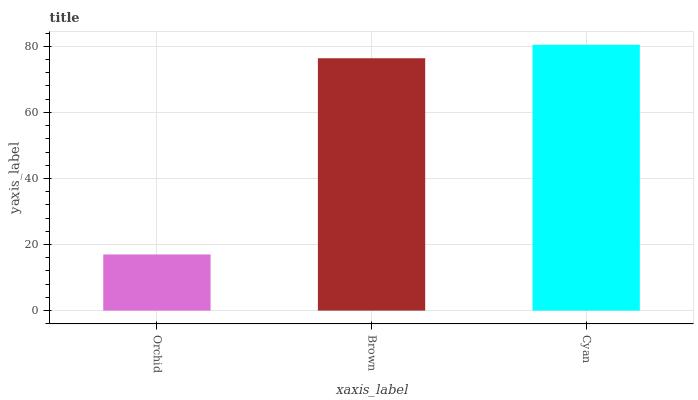Is Brown the minimum?
Answer yes or no. No. Is Brown the maximum?
Answer yes or no. No. Is Brown greater than Orchid?
Answer yes or no. Yes. Is Orchid less than Brown?
Answer yes or no. Yes. Is Orchid greater than Brown?
Answer yes or no. No. Is Brown less than Orchid?
Answer yes or no. No. Is Brown the high median?
Answer yes or no. Yes. Is Brown the low median?
Answer yes or no. Yes. Is Cyan the high median?
Answer yes or no. No. Is Orchid the low median?
Answer yes or no. No. 